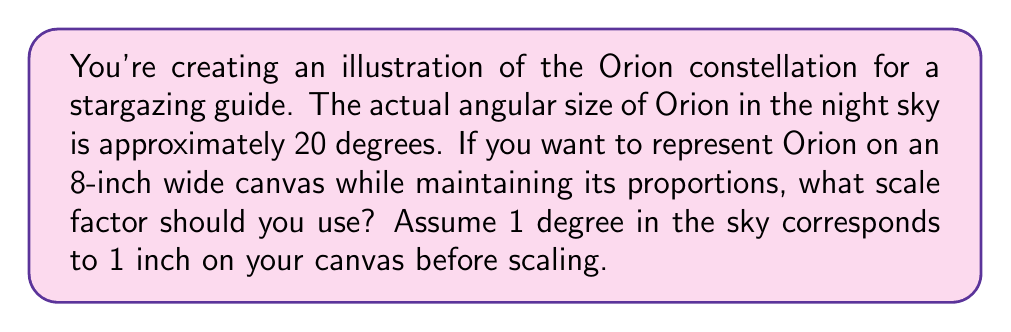Can you solve this math problem? To solve this problem, we need to follow these steps:

1. Understand the given information:
   - Orion's actual angular size: 20 degrees
   - Canvas width: 8 inches
   - 1 degree in sky = 1 inch on canvas (before scaling)

2. Calculate the size of Orion before scaling:
   $20 \text{ degrees} \times \frac{1 \text{ inch}}{1 \text{ degree}} = 20 \text{ inches}$

3. Determine the scale factor:
   The scale factor is the ratio of the desired size to the original size.
   
   $$\text{Scale factor} = \frac{\text{Desired size}}{\text{Original size}} = \frac{8 \text{ inches}}{20 \text{ inches}}$$

4. Simplify the fraction:
   $$\text{Scale factor} = \frac{8}{20} = \frac{2}{5} = 0.4$$

Therefore, the scale factor needed to accurately represent Orion's size on the 8-inch canvas is 0.4 or 2/5.
Answer: 0.4 